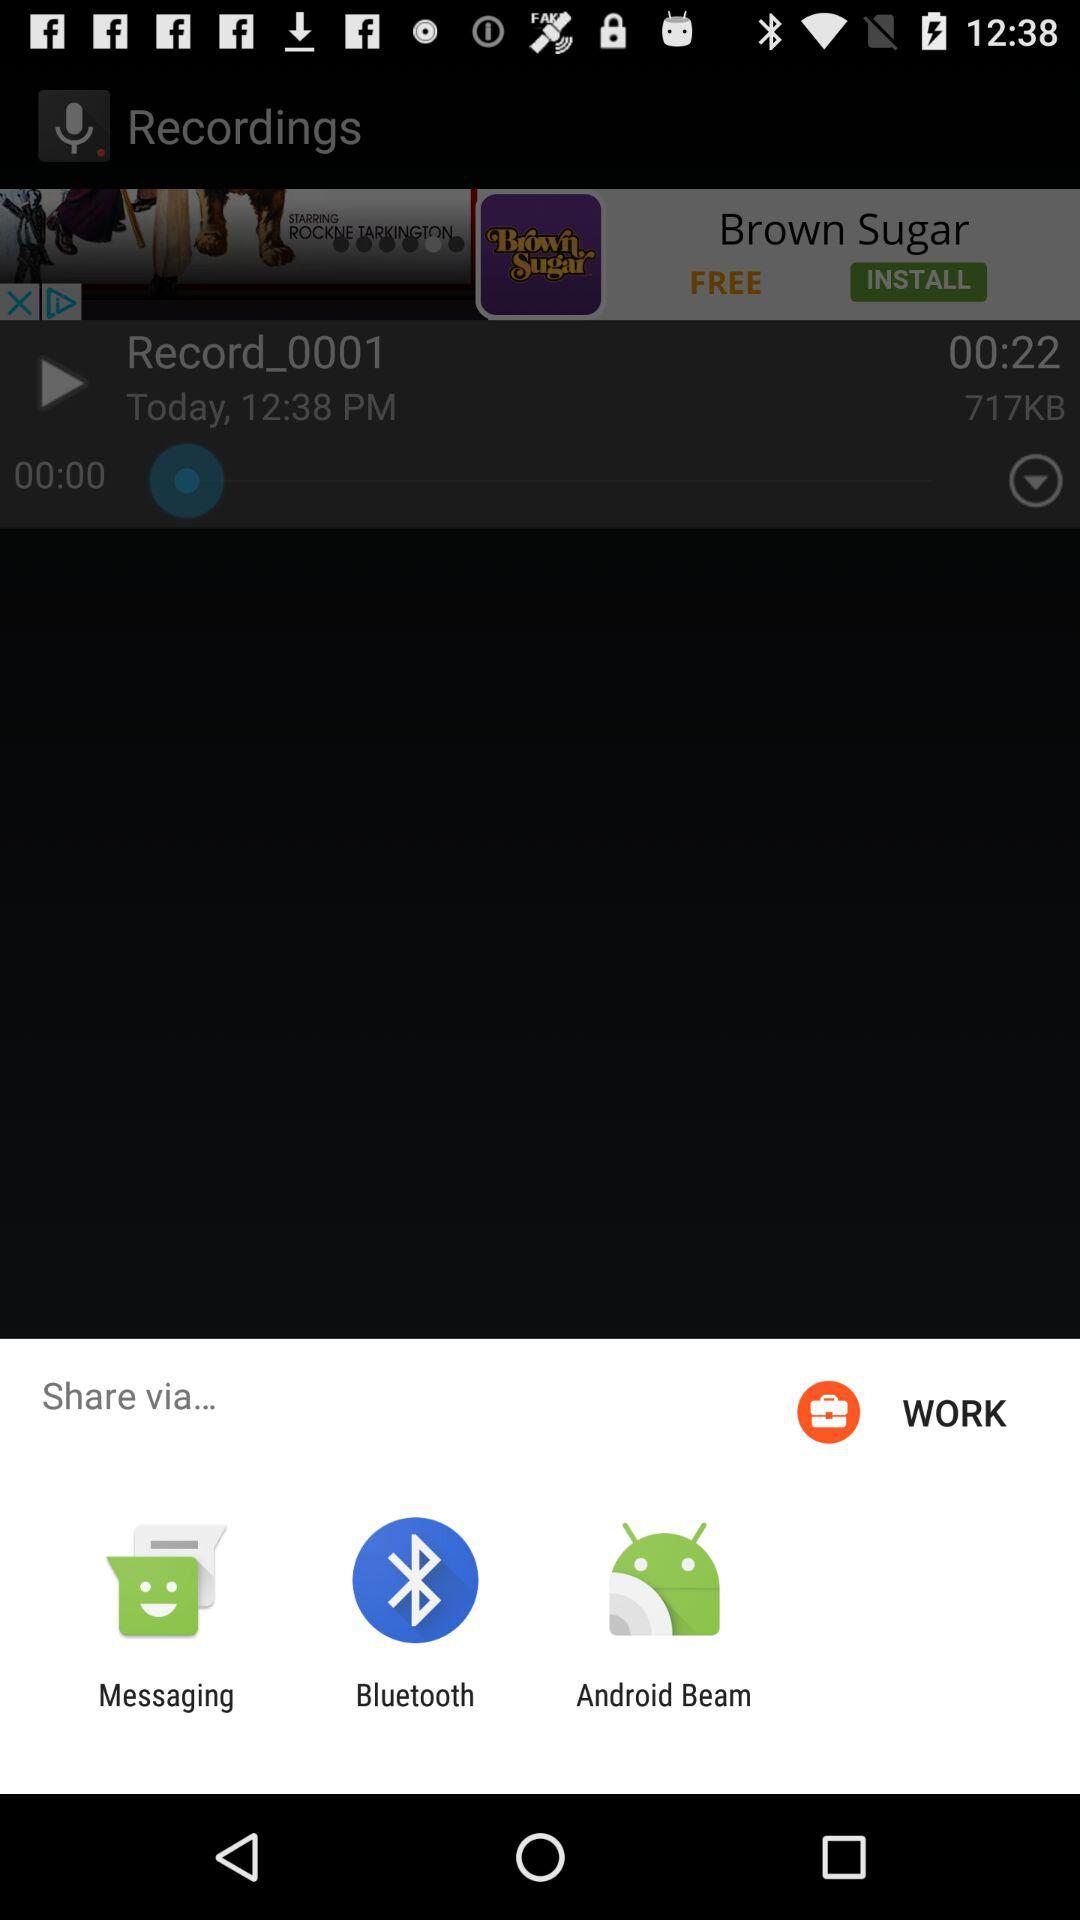Through what application can we share? You can share through "Messaging", "Bluetooth" and "Android Beam". 